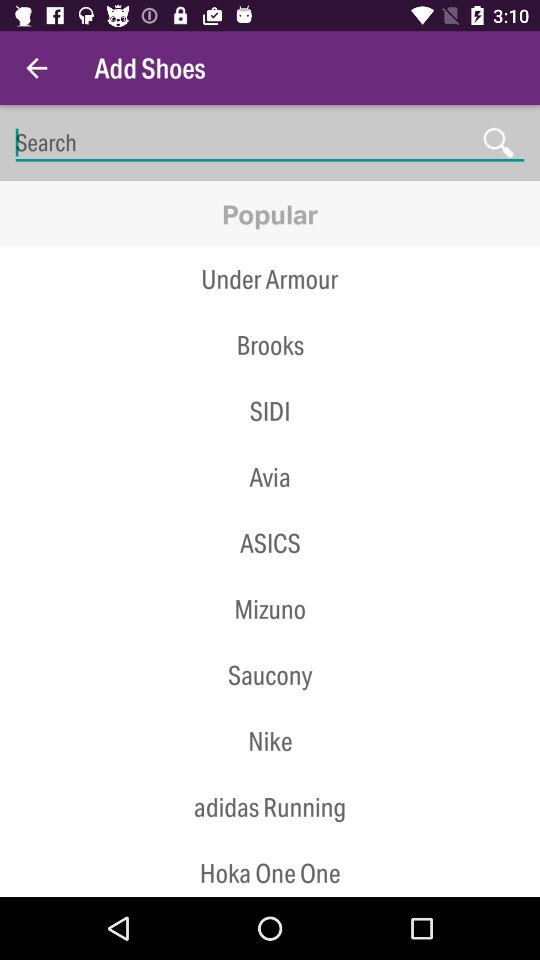Who is adding shoes?
When the provided information is insufficient, respond with <no answer>. <no answer> 